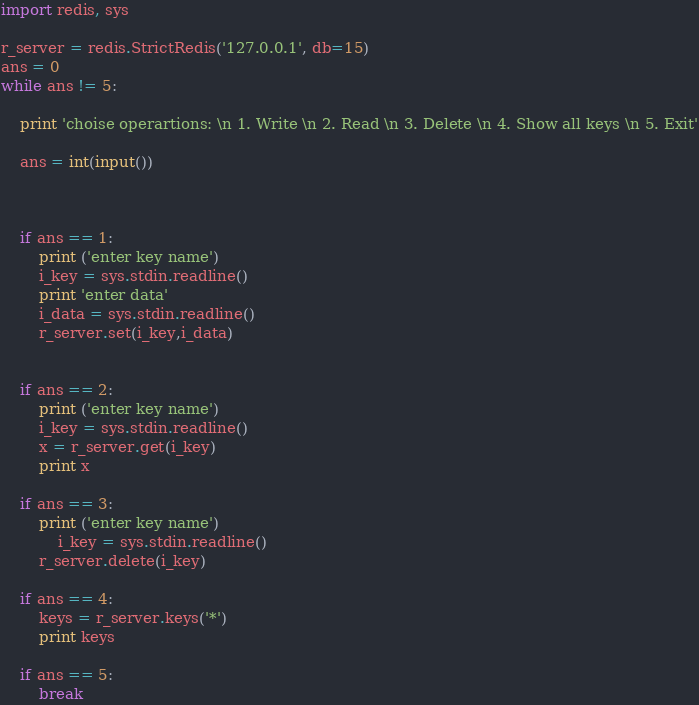<code> <loc_0><loc_0><loc_500><loc_500><_Python_>import redis, sys

r_server = redis.StrictRedis('127.0.0.1', db=15)
ans = 0
while ans != 5:

	print 'choise operartions: \n 1. Write \n 2. Read \n 3. Delete \n 4. Show all keys \n 5. Exit'

	ans = int(input())



	if ans == 1:
		print ('enter key name')
		i_key = sys.stdin.readline()
		print 'enter data'
		i_data = sys.stdin.readline()
		r_server.set(i_key,i_data)
	

	if ans == 2:
		print ('enter key name')
		i_key = sys.stdin.readline()
		x = r_server.get(i_key)
		print x

	if ans == 3:
		print ('enter key name')
	        i_key = sys.stdin.readline()
		r_server.delete(i_key)

	if ans == 4:
		keys = r_server.keys('*')
		print keys

	if ans == 5:
		break
</code> 